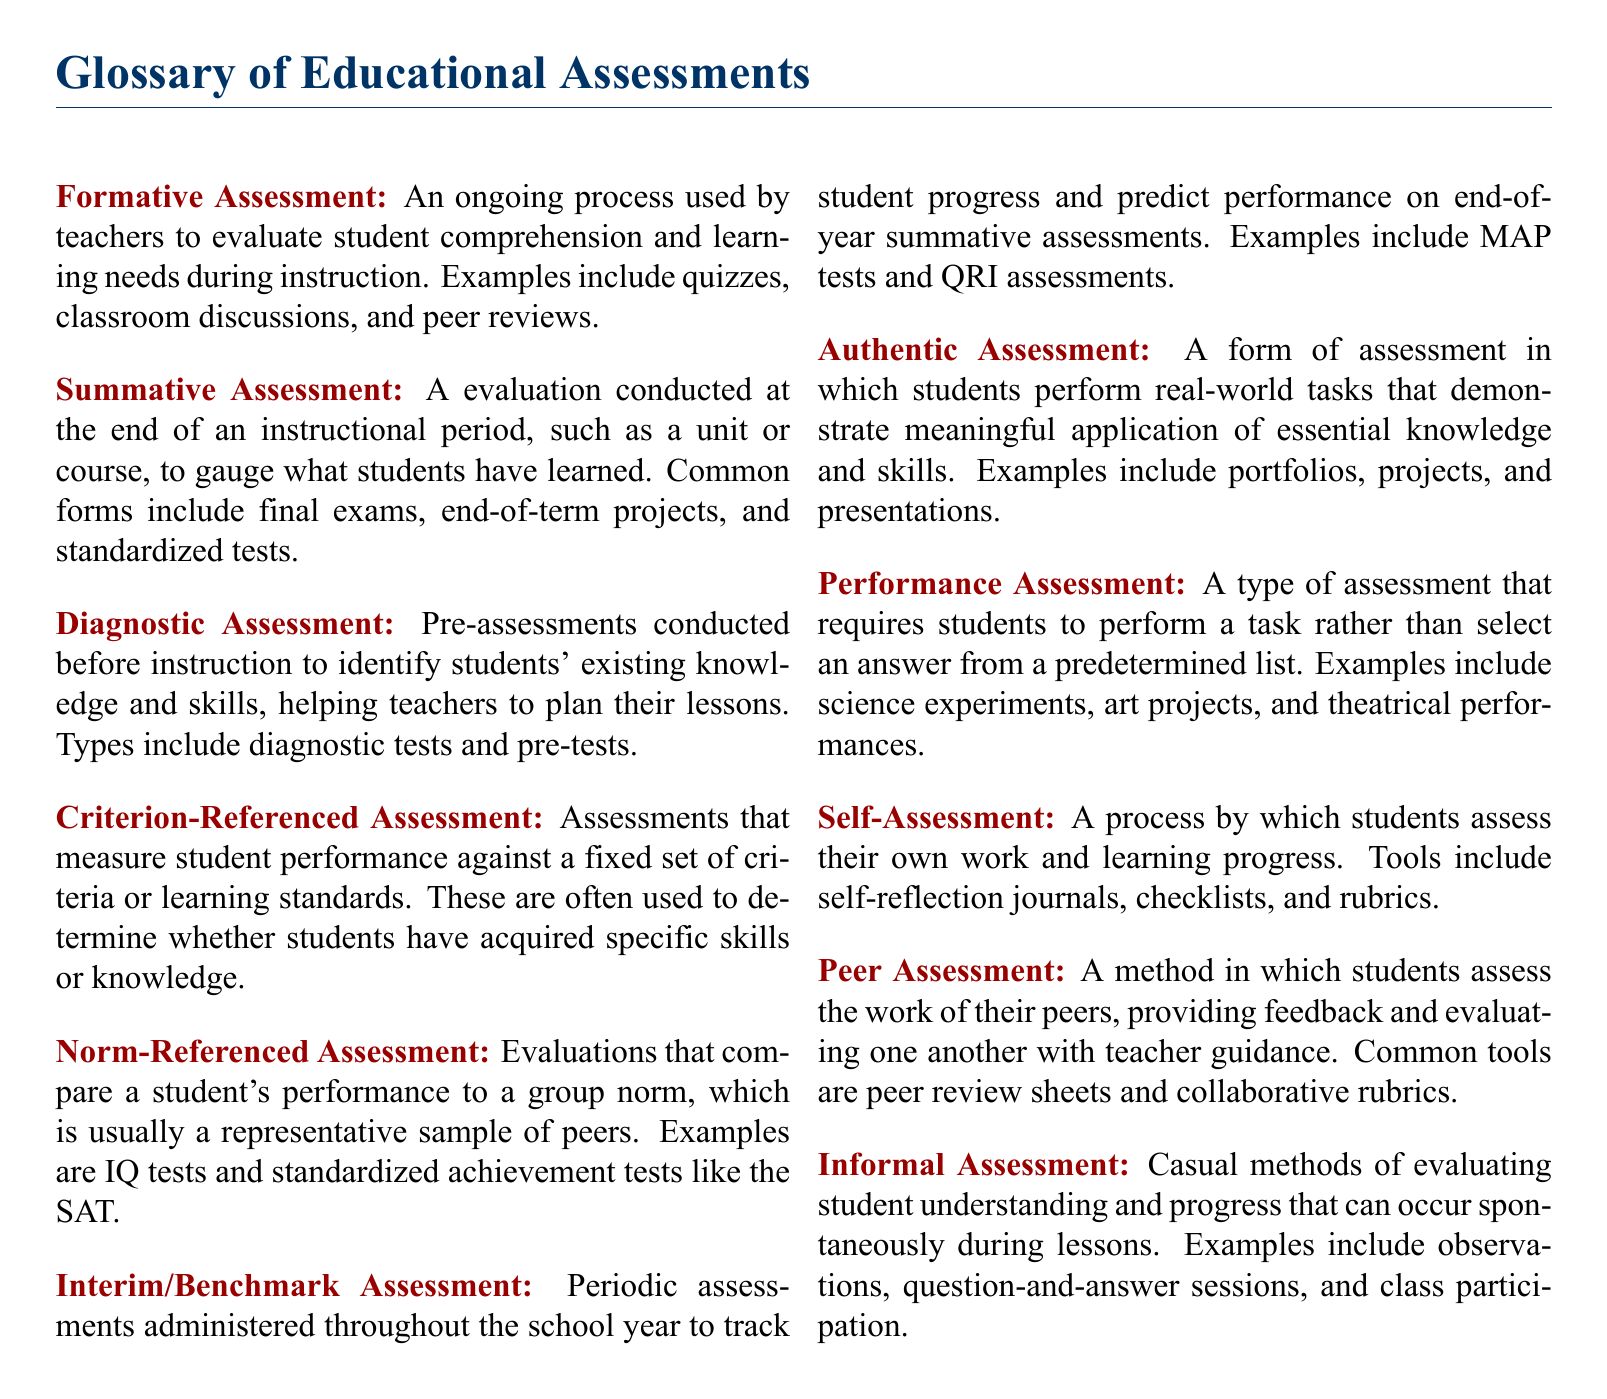What is a formative assessment? A formative assessment is defined in the document as an ongoing process used by teachers to evaluate student comprehension and learning needs during instruction.
Answer: ongoing process What type of assessment occurs at the end of an instructional period? The document states that a summative assessment is conducted at the end of an instructional period to measure what students have learned.
Answer: summative assessment What is the purpose of a diagnostic assessment? The purpose of a diagnostic assessment is to identify students' existing knowledge and skills before instruction.
Answer: identify existing knowledge What do criterion-referenced assessments measure? According to the document, criterion-referenced assessments measure student performance against a fixed set of criteria or learning standards.
Answer: fixed criteria What is one example of an authentic assessment? The document provides examples of authentic assessments, one of which is portfolios.
Answer: portfolios What is the main difference between norm-referenced and criterion-referenced assessments? The main difference is that norm-referenced assessments compare a student's performance to peers, whereas criterion-referenced assessments measure against standards.
Answer: performance comparison How often are interim assessments administered? The document describes interim assessments as periodic, administered throughout the school year.
Answer: periodically What type of assessment involves students evaluating peer work? The document mentions peer assessments as the method in which students assess the work of their peers.
Answer: peer assessment What kind of assessment is performed by students on their own work? The type of assessment where students assess their own work is called self-assessment.
Answer: self-assessment 